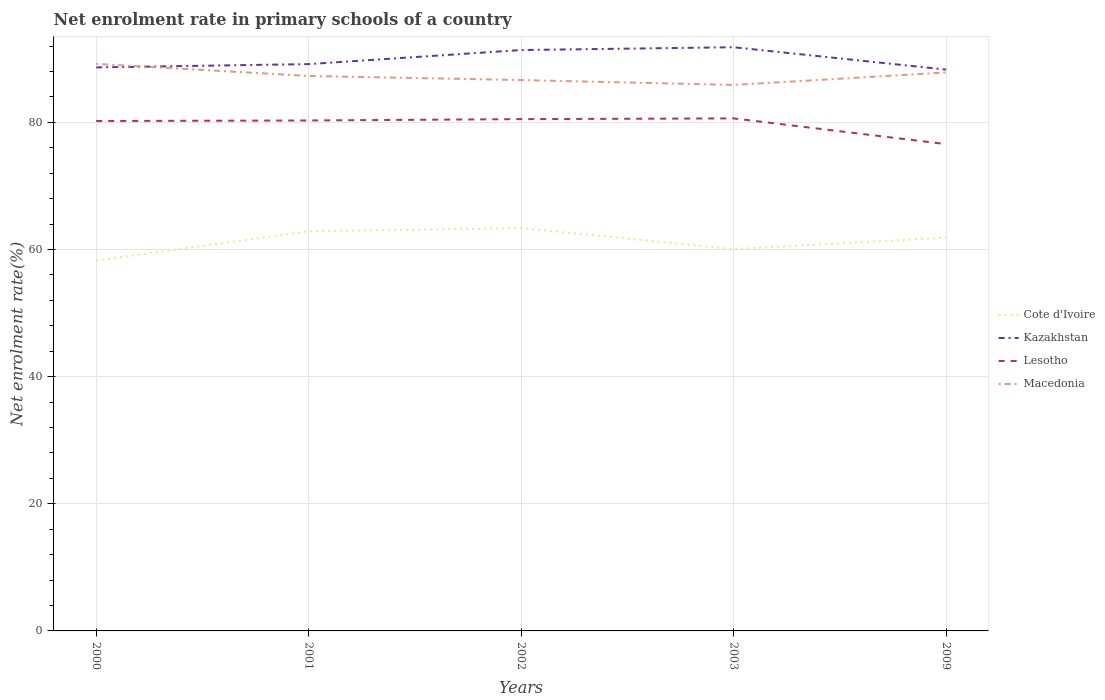How many different coloured lines are there?
Provide a short and direct response. 4. Across all years, what is the maximum net enrolment rate in primary schools in Macedonia?
Your answer should be very brief. 85.88. What is the total net enrolment rate in primary schools in Lesotho in the graph?
Your answer should be compact. 3.72. What is the difference between the highest and the second highest net enrolment rate in primary schools in Lesotho?
Your answer should be very brief. 4.05. What is the difference between the highest and the lowest net enrolment rate in primary schools in Cote d'Ivoire?
Ensure brevity in your answer.  3. Is the net enrolment rate in primary schools in Macedonia strictly greater than the net enrolment rate in primary schools in Lesotho over the years?
Ensure brevity in your answer.  No. What is the difference between two consecutive major ticks on the Y-axis?
Offer a terse response. 20. Does the graph contain any zero values?
Give a very brief answer. No. Does the graph contain grids?
Provide a succinct answer. Yes. How are the legend labels stacked?
Offer a very short reply. Vertical. What is the title of the graph?
Your response must be concise. Net enrolment rate in primary schools of a country. Does "Sierra Leone" appear as one of the legend labels in the graph?
Your answer should be compact. No. What is the label or title of the X-axis?
Provide a succinct answer. Years. What is the label or title of the Y-axis?
Make the answer very short. Net enrolment rate(%). What is the Net enrolment rate(%) in Cote d'Ivoire in 2000?
Your response must be concise. 58.26. What is the Net enrolment rate(%) of Kazakhstan in 2000?
Make the answer very short. 88.63. What is the Net enrolment rate(%) of Lesotho in 2000?
Your answer should be compact. 80.2. What is the Net enrolment rate(%) of Macedonia in 2000?
Give a very brief answer. 89.19. What is the Net enrolment rate(%) in Cote d'Ivoire in 2001?
Give a very brief answer. 62.86. What is the Net enrolment rate(%) in Kazakhstan in 2001?
Your answer should be very brief. 89.15. What is the Net enrolment rate(%) of Lesotho in 2001?
Provide a succinct answer. 80.29. What is the Net enrolment rate(%) of Macedonia in 2001?
Your answer should be very brief. 87.29. What is the Net enrolment rate(%) of Cote d'Ivoire in 2002?
Make the answer very short. 63.36. What is the Net enrolment rate(%) of Kazakhstan in 2002?
Your response must be concise. 91.36. What is the Net enrolment rate(%) of Lesotho in 2002?
Offer a terse response. 80.5. What is the Net enrolment rate(%) in Macedonia in 2002?
Provide a succinct answer. 86.64. What is the Net enrolment rate(%) in Cote d'Ivoire in 2003?
Offer a terse response. 60.05. What is the Net enrolment rate(%) of Kazakhstan in 2003?
Make the answer very short. 91.81. What is the Net enrolment rate(%) of Lesotho in 2003?
Provide a succinct answer. 80.61. What is the Net enrolment rate(%) of Macedonia in 2003?
Your response must be concise. 85.88. What is the Net enrolment rate(%) in Cote d'Ivoire in 2009?
Your answer should be very brief. 61.86. What is the Net enrolment rate(%) of Kazakhstan in 2009?
Provide a succinct answer. 88.29. What is the Net enrolment rate(%) of Lesotho in 2009?
Give a very brief answer. 76.57. What is the Net enrolment rate(%) of Macedonia in 2009?
Provide a short and direct response. 87.84. Across all years, what is the maximum Net enrolment rate(%) in Cote d'Ivoire?
Your answer should be compact. 63.36. Across all years, what is the maximum Net enrolment rate(%) of Kazakhstan?
Keep it short and to the point. 91.81. Across all years, what is the maximum Net enrolment rate(%) in Lesotho?
Your answer should be compact. 80.61. Across all years, what is the maximum Net enrolment rate(%) of Macedonia?
Keep it short and to the point. 89.19. Across all years, what is the minimum Net enrolment rate(%) in Cote d'Ivoire?
Make the answer very short. 58.26. Across all years, what is the minimum Net enrolment rate(%) in Kazakhstan?
Your answer should be very brief. 88.29. Across all years, what is the minimum Net enrolment rate(%) of Lesotho?
Provide a succinct answer. 76.57. Across all years, what is the minimum Net enrolment rate(%) of Macedonia?
Your answer should be compact. 85.88. What is the total Net enrolment rate(%) of Cote d'Ivoire in the graph?
Keep it short and to the point. 306.39. What is the total Net enrolment rate(%) of Kazakhstan in the graph?
Ensure brevity in your answer.  449.24. What is the total Net enrolment rate(%) of Lesotho in the graph?
Provide a short and direct response. 398.16. What is the total Net enrolment rate(%) of Macedonia in the graph?
Your answer should be very brief. 436.83. What is the difference between the Net enrolment rate(%) in Cote d'Ivoire in 2000 and that in 2001?
Ensure brevity in your answer.  -4.6. What is the difference between the Net enrolment rate(%) of Kazakhstan in 2000 and that in 2001?
Make the answer very short. -0.52. What is the difference between the Net enrolment rate(%) in Lesotho in 2000 and that in 2001?
Offer a terse response. -0.09. What is the difference between the Net enrolment rate(%) in Macedonia in 2000 and that in 2001?
Keep it short and to the point. 1.9. What is the difference between the Net enrolment rate(%) in Cote d'Ivoire in 2000 and that in 2002?
Provide a succinct answer. -5.1. What is the difference between the Net enrolment rate(%) in Kazakhstan in 2000 and that in 2002?
Your response must be concise. -2.73. What is the difference between the Net enrolment rate(%) in Lesotho in 2000 and that in 2002?
Provide a succinct answer. -0.3. What is the difference between the Net enrolment rate(%) in Macedonia in 2000 and that in 2002?
Your response must be concise. 2.54. What is the difference between the Net enrolment rate(%) of Cote d'Ivoire in 2000 and that in 2003?
Provide a short and direct response. -1.8. What is the difference between the Net enrolment rate(%) of Kazakhstan in 2000 and that in 2003?
Offer a terse response. -3.17. What is the difference between the Net enrolment rate(%) in Lesotho in 2000 and that in 2003?
Your answer should be compact. -0.41. What is the difference between the Net enrolment rate(%) of Macedonia in 2000 and that in 2003?
Provide a short and direct response. 3.31. What is the difference between the Net enrolment rate(%) in Kazakhstan in 2000 and that in 2009?
Your answer should be compact. 0.34. What is the difference between the Net enrolment rate(%) of Lesotho in 2000 and that in 2009?
Your answer should be compact. 3.64. What is the difference between the Net enrolment rate(%) of Macedonia in 2000 and that in 2009?
Offer a very short reply. 1.35. What is the difference between the Net enrolment rate(%) of Cote d'Ivoire in 2001 and that in 2002?
Your answer should be very brief. -0.5. What is the difference between the Net enrolment rate(%) of Kazakhstan in 2001 and that in 2002?
Make the answer very short. -2.21. What is the difference between the Net enrolment rate(%) in Lesotho in 2001 and that in 2002?
Make the answer very short. -0.21. What is the difference between the Net enrolment rate(%) of Macedonia in 2001 and that in 2002?
Your response must be concise. 0.64. What is the difference between the Net enrolment rate(%) in Cote d'Ivoire in 2001 and that in 2003?
Offer a very short reply. 2.81. What is the difference between the Net enrolment rate(%) in Kazakhstan in 2001 and that in 2003?
Provide a short and direct response. -2.65. What is the difference between the Net enrolment rate(%) in Lesotho in 2001 and that in 2003?
Provide a succinct answer. -0.33. What is the difference between the Net enrolment rate(%) in Macedonia in 2001 and that in 2003?
Keep it short and to the point. 1.41. What is the difference between the Net enrolment rate(%) of Cote d'Ivoire in 2001 and that in 2009?
Offer a very short reply. 1. What is the difference between the Net enrolment rate(%) in Kazakhstan in 2001 and that in 2009?
Ensure brevity in your answer.  0.86. What is the difference between the Net enrolment rate(%) in Lesotho in 2001 and that in 2009?
Keep it short and to the point. 3.72. What is the difference between the Net enrolment rate(%) in Macedonia in 2001 and that in 2009?
Offer a very short reply. -0.55. What is the difference between the Net enrolment rate(%) in Cote d'Ivoire in 2002 and that in 2003?
Your response must be concise. 3.3. What is the difference between the Net enrolment rate(%) of Kazakhstan in 2002 and that in 2003?
Your answer should be compact. -0.44. What is the difference between the Net enrolment rate(%) in Lesotho in 2002 and that in 2003?
Keep it short and to the point. -0.11. What is the difference between the Net enrolment rate(%) in Macedonia in 2002 and that in 2003?
Make the answer very short. 0.77. What is the difference between the Net enrolment rate(%) in Cote d'Ivoire in 2002 and that in 2009?
Your response must be concise. 1.5. What is the difference between the Net enrolment rate(%) of Kazakhstan in 2002 and that in 2009?
Ensure brevity in your answer.  3.08. What is the difference between the Net enrolment rate(%) in Lesotho in 2002 and that in 2009?
Your response must be concise. 3.93. What is the difference between the Net enrolment rate(%) of Macedonia in 2002 and that in 2009?
Offer a terse response. -1.19. What is the difference between the Net enrolment rate(%) in Cote d'Ivoire in 2003 and that in 2009?
Your response must be concise. -1.8. What is the difference between the Net enrolment rate(%) of Kazakhstan in 2003 and that in 2009?
Your answer should be very brief. 3.52. What is the difference between the Net enrolment rate(%) in Lesotho in 2003 and that in 2009?
Give a very brief answer. 4.05. What is the difference between the Net enrolment rate(%) in Macedonia in 2003 and that in 2009?
Offer a very short reply. -1.96. What is the difference between the Net enrolment rate(%) in Cote d'Ivoire in 2000 and the Net enrolment rate(%) in Kazakhstan in 2001?
Provide a succinct answer. -30.89. What is the difference between the Net enrolment rate(%) in Cote d'Ivoire in 2000 and the Net enrolment rate(%) in Lesotho in 2001?
Make the answer very short. -22.03. What is the difference between the Net enrolment rate(%) in Cote d'Ivoire in 2000 and the Net enrolment rate(%) in Macedonia in 2001?
Offer a terse response. -29.03. What is the difference between the Net enrolment rate(%) of Kazakhstan in 2000 and the Net enrolment rate(%) of Lesotho in 2001?
Offer a terse response. 8.35. What is the difference between the Net enrolment rate(%) of Kazakhstan in 2000 and the Net enrolment rate(%) of Macedonia in 2001?
Give a very brief answer. 1.35. What is the difference between the Net enrolment rate(%) in Lesotho in 2000 and the Net enrolment rate(%) in Macedonia in 2001?
Keep it short and to the point. -7.09. What is the difference between the Net enrolment rate(%) of Cote d'Ivoire in 2000 and the Net enrolment rate(%) of Kazakhstan in 2002?
Keep it short and to the point. -33.11. What is the difference between the Net enrolment rate(%) of Cote d'Ivoire in 2000 and the Net enrolment rate(%) of Lesotho in 2002?
Give a very brief answer. -22.24. What is the difference between the Net enrolment rate(%) in Cote d'Ivoire in 2000 and the Net enrolment rate(%) in Macedonia in 2002?
Ensure brevity in your answer.  -28.39. What is the difference between the Net enrolment rate(%) in Kazakhstan in 2000 and the Net enrolment rate(%) in Lesotho in 2002?
Provide a short and direct response. 8.13. What is the difference between the Net enrolment rate(%) of Kazakhstan in 2000 and the Net enrolment rate(%) of Macedonia in 2002?
Keep it short and to the point. 1.99. What is the difference between the Net enrolment rate(%) of Lesotho in 2000 and the Net enrolment rate(%) of Macedonia in 2002?
Provide a succinct answer. -6.44. What is the difference between the Net enrolment rate(%) of Cote d'Ivoire in 2000 and the Net enrolment rate(%) of Kazakhstan in 2003?
Your answer should be compact. -33.55. What is the difference between the Net enrolment rate(%) of Cote d'Ivoire in 2000 and the Net enrolment rate(%) of Lesotho in 2003?
Your answer should be very brief. -22.36. What is the difference between the Net enrolment rate(%) in Cote d'Ivoire in 2000 and the Net enrolment rate(%) in Macedonia in 2003?
Offer a very short reply. -27.62. What is the difference between the Net enrolment rate(%) of Kazakhstan in 2000 and the Net enrolment rate(%) of Lesotho in 2003?
Keep it short and to the point. 8.02. What is the difference between the Net enrolment rate(%) of Kazakhstan in 2000 and the Net enrolment rate(%) of Macedonia in 2003?
Ensure brevity in your answer.  2.76. What is the difference between the Net enrolment rate(%) in Lesotho in 2000 and the Net enrolment rate(%) in Macedonia in 2003?
Keep it short and to the point. -5.68. What is the difference between the Net enrolment rate(%) of Cote d'Ivoire in 2000 and the Net enrolment rate(%) of Kazakhstan in 2009?
Keep it short and to the point. -30.03. What is the difference between the Net enrolment rate(%) of Cote d'Ivoire in 2000 and the Net enrolment rate(%) of Lesotho in 2009?
Give a very brief answer. -18.31. What is the difference between the Net enrolment rate(%) in Cote d'Ivoire in 2000 and the Net enrolment rate(%) in Macedonia in 2009?
Your answer should be compact. -29.58. What is the difference between the Net enrolment rate(%) in Kazakhstan in 2000 and the Net enrolment rate(%) in Lesotho in 2009?
Ensure brevity in your answer.  12.07. What is the difference between the Net enrolment rate(%) of Kazakhstan in 2000 and the Net enrolment rate(%) of Macedonia in 2009?
Give a very brief answer. 0.8. What is the difference between the Net enrolment rate(%) in Lesotho in 2000 and the Net enrolment rate(%) in Macedonia in 2009?
Provide a short and direct response. -7.64. What is the difference between the Net enrolment rate(%) in Cote d'Ivoire in 2001 and the Net enrolment rate(%) in Kazakhstan in 2002?
Ensure brevity in your answer.  -28.5. What is the difference between the Net enrolment rate(%) of Cote d'Ivoire in 2001 and the Net enrolment rate(%) of Lesotho in 2002?
Your answer should be very brief. -17.64. What is the difference between the Net enrolment rate(%) of Cote d'Ivoire in 2001 and the Net enrolment rate(%) of Macedonia in 2002?
Your response must be concise. -23.78. What is the difference between the Net enrolment rate(%) of Kazakhstan in 2001 and the Net enrolment rate(%) of Lesotho in 2002?
Your response must be concise. 8.65. What is the difference between the Net enrolment rate(%) of Kazakhstan in 2001 and the Net enrolment rate(%) of Macedonia in 2002?
Offer a terse response. 2.51. What is the difference between the Net enrolment rate(%) of Lesotho in 2001 and the Net enrolment rate(%) of Macedonia in 2002?
Offer a very short reply. -6.36. What is the difference between the Net enrolment rate(%) of Cote d'Ivoire in 2001 and the Net enrolment rate(%) of Kazakhstan in 2003?
Ensure brevity in your answer.  -28.94. What is the difference between the Net enrolment rate(%) in Cote d'Ivoire in 2001 and the Net enrolment rate(%) in Lesotho in 2003?
Provide a succinct answer. -17.75. What is the difference between the Net enrolment rate(%) of Cote d'Ivoire in 2001 and the Net enrolment rate(%) of Macedonia in 2003?
Your response must be concise. -23.01. What is the difference between the Net enrolment rate(%) of Kazakhstan in 2001 and the Net enrolment rate(%) of Lesotho in 2003?
Make the answer very short. 8.54. What is the difference between the Net enrolment rate(%) of Kazakhstan in 2001 and the Net enrolment rate(%) of Macedonia in 2003?
Give a very brief answer. 3.27. What is the difference between the Net enrolment rate(%) in Lesotho in 2001 and the Net enrolment rate(%) in Macedonia in 2003?
Provide a short and direct response. -5.59. What is the difference between the Net enrolment rate(%) in Cote d'Ivoire in 2001 and the Net enrolment rate(%) in Kazakhstan in 2009?
Your response must be concise. -25.43. What is the difference between the Net enrolment rate(%) in Cote d'Ivoire in 2001 and the Net enrolment rate(%) in Lesotho in 2009?
Give a very brief answer. -13.7. What is the difference between the Net enrolment rate(%) of Cote d'Ivoire in 2001 and the Net enrolment rate(%) of Macedonia in 2009?
Offer a terse response. -24.97. What is the difference between the Net enrolment rate(%) in Kazakhstan in 2001 and the Net enrolment rate(%) in Lesotho in 2009?
Give a very brief answer. 12.59. What is the difference between the Net enrolment rate(%) of Kazakhstan in 2001 and the Net enrolment rate(%) of Macedonia in 2009?
Your response must be concise. 1.31. What is the difference between the Net enrolment rate(%) of Lesotho in 2001 and the Net enrolment rate(%) of Macedonia in 2009?
Your response must be concise. -7.55. What is the difference between the Net enrolment rate(%) in Cote d'Ivoire in 2002 and the Net enrolment rate(%) in Kazakhstan in 2003?
Your answer should be very brief. -28.45. What is the difference between the Net enrolment rate(%) of Cote d'Ivoire in 2002 and the Net enrolment rate(%) of Lesotho in 2003?
Offer a very short reply. -17.25. What is the difference between the Net enrolment rate(%) of Cote d'Ivoire in 2002 and the Net enrolment rate(%) of Macedonia in 2003?
Keep it short and to the point. -22.52. What is the difference between the Net enrolment rate(%) of Kazakhstan in 2002 and the Net enrolment rate(%) of Lesotho in 2003?
Your answer should be very brief. 10.75. What is the difference between the Net enrolment rate(%) in Kazakhstan in 2002 and the Net enrolment rate(%) in Macedonia in 2003?
Provide a short and direct response. 5.49. What is the difference between the Net enrolment rate(%) in Lesotho in 2002 and the Net enrolment rate(%) in Macedonia in 2003?
Ensure brevity in your answer.  -5.38. What is the difference between the Net enrolment rate(%) of Cote d'Ivoire in 2002 and the Net enrolment rate(%) of Kazakhstan in 2009?
Provide a succinct answer. -24.93. What is the difference between the Net enrolment rate(%) of Cote d'Ivoire in 2002 and the Net enrolment rate(%) of Lesotho in 2009?
Your answer should be compact. -13.21. What is the difference between the Net enrolment rate(%) in Cote d'Ivoire in 2002 and the Net enrolment rate(%) in Macedonia in 2009?
Your answer should be compact. -24.48. What is the difference between the Net enrolment rate(%) of Kazakhstan in 2002 and the Net enrolment rate(%) of Lesotho in 2009?
Your answer should be compact. 14.8. What is the difference between the Net enrolment rate(%) in Kazakhstan in 2002 and the Net enrolment rate(%) in Macedonia in 2009?
Your answer should be compact. 3.53. What is the difference between the Net enrolment rate(%) of Lesotho in 2002 and the Net enrolment rate(%) of Macedonia in 2009?
Provide a succinct answer. -7.34. What is the difference between the Net enrolment rate(%) of Cote d'Ivoire in 2003 and the Net enrolment rate(%) of Kazakhstan in 2009?
Give a very brief answer. -28.23. What is the difference between the Net enrolment rate(%) of Cote d'Ivoire in 2003 and the Net enrolment rate(%) of Lesotho in 2009?
Ensure brevity in your answer.  -16.51. What is the difference between the Net enrolment rate(%) of Cote d'Ivoire in 2003 and the Net enrolment rate(%) of Macedonia in 2009?
Make the answer very short. -27.78. What is the difference between the Net enrolment rate(%) in Kazakhstan in 2003 and the Net enrolment rate(%) in Lesotho in 2009?
Your answer should be very brief. 15.24. What is the difference between the Net enrolment rate(%) of Kazakhstan in 2003 and the Net enrolment rate(%) of Macedonia in 2009?
Give a very brief answer. 3.97. What is the difference between the Net enrolment rate(%) of Lesotho in 2003 and the Net enrolment rate(%) of Macedonia in 2009?
Your response must be concise. -7.22. What is the average Net enrolment rate(%) of Cote d'Ivoire per year?
Keep it short and to the point. 61.28. What is the average Net enrolment rate(%) in Kazakhstan per year?
Offer a very short reply. 89.85. What is the average Net enrolment rate(%) in Lesotho per year?
Provide a short and direct response. 79.63. What is the average Net enrolment rate(%) in Macedonia per year?
Provide a succinct answer. 87.37. In the year 2000, what is the difference between the Net enrolment rate(%) of Cote d'Ivoire and Net enrolment rate(%) of Kazakhstan?
Provide a short and direct response. -30.38. In the year 2000, what is the difference between the Net enrolment rate(%) in Cote d'Ivoire and Net enrolment rate(%) in Lesotho?
Your response must be concise. -21.94. In the year 2000, what is the difference between the Net enrolment rate(%) of Cote d'Ivoire and Net enrolment rate(%) of Macedonia?
Ensure brevity in your answer.  -30.93. In the year 2000, what is the difference between the Net enrolment rate(%) in Kazakhstan and Net enrolment rate(%) in Lesotho?
Provide a short and direct response. 8.43. In the year 2000, what is the difference between the Net enrolment rate(%) of Kazakhstan and Net enrolment rate(%) of Macedonia?
Make the answer very short. -0.55. In the year 2000, what is the difference between the Net enrolment rate(%) in Lesotho and Net enrolment rate(%) in Macedonia?
Give a very brief answer. -8.99. In the year 2001, what is the difference between the Net enrolment rate(%) of Cote d'Ivoire and Net enrolment rate(%) of Kazakhstan?
Give a very brief answer. -26.29. In the year 2001, what is the difference between the Net enrolment rate(%) of Cote d'Ivoire and Net enrolment rate(%) of Lesotho?
Give a very brief answer. -17.42. In the year 2001, what is the difference between the Net enrolment rate(%) of Cote d'Ivoire and Net enrolment rate(%) of Macedonia?
Your answer should be very brief. -24.43. In the year 2001, what is the difference between the Net enrolment rate(%) of Kazakhstan and Net enrolment rate(%) of Lesotho?
Provide a short and direct response. 8.87. In the year 2001, what is the difference between the Net enrolment rate(%) of Kazakhstan and Net enrolment rate(%) of Macedonia?
Provide a succinct answer. 1.86. In the year 2001, what is the difference between the Net enrolment rate(%) in Lesotho and Net enrolment rate(%) in Macedonia?
Give a very brief answer. -7. In the year 2002, what is the difference between the Net enrolment rate(%) in Cote d'Ivoire and Net enrolment rate(%) in Kazakhstan?
Your answer should be very brief. -28.01. In the year 2002, what is the difference between the Net enrolment rate(%) of Cote d'Ivoire and Net enrolment rate(%) of Lesotho?
Provide a succinct answer. -17.14. In the year 2002, what is the difference between the Net enrolment rate(%) of Cote d'Ivoire and Net enrolment rate(%) of Macedonia?
Give a very brief answer. -23.29. In the year 2002, what is the difference between the Net enrolment rate(%) in Kazakhstan and Net enrolment rate(%) in Lesotho?
Keep it short and to the point. 10.87. In the year 2002, what is the difference between the Net enrolment rate(%) in Kazakhstan and Net enrolment rate(%) in Macedonia?
Ensure brevity in your answer.  4.72. In the year 2002, what is the difference between the Net enrolment rate(%) of Lesotho and Net enrolment rate(%) of Macedonia?
Provide a short and direct response. -6.15. In the year 2003, what is the difference between the Net enrolment rate(%) of Cote d'Ivoire and Net enrolment rate(%) of Kazakhstan?
Ensure brevity in your answer.  -31.75. In the year 2003, what is the difference between the Net enrolment rate(%) in Cote d'Ivoire and Net enrolment rate(%) in Lesotho?
Offer a terse response. -20.56. In the year 2003, what is the difference between the Net enrolment rate(%) in Cote d'Ivoire and Net enrolment rate(%) in Macedonia?
Provide a short and direct response. -25.82. In the year 2003, what is the difference between the Net enrolment rate(%) in Kazakhstan and Net enrolment rate(%) in Lesotho?
Your response must be concise. 11.19. In the year 2003, what is the difference between the Net enrolment rate(%) in Kazakhstan and Net enrolment rate(%) in Macedonia?
Ensure brevity in your answer.  5.93. In the year 2003, what is the difference between the Net enrolment rate(%) of Lesotho and Net enrolment rate(%) of Macedonia?
Keep it short and to the point. -5.26. In the year 2009, what is the difference between the Net enrolment rate(%) in Cote d'Ivoire and Net enrolment rate(%) in Kazakhstan?
Offer a terse response. -26.43. In the year 2009, what is the difference between the Net enrolment rate(%) in Cote d'Ivoire and Net enrolment rate(%) in Lesotho?
Offer a terse response. -14.71. In the year 2009, what is the difference between the Net enrolment rate(%) in Cote d'Ivoire and Net enrolment rate(%) in Macedonia?
Keep it short and to the point. -25.98. In the year 2009, what is the difference between the Net enrolment rate(%) in Kazakhstan and Net enrolment rate(%) in Lesotho?
Keep it short and to the point. 11.72. In the year 2009, what is the difference between the Net enrolment rate(%) in Kazakhstan and Net enrolment rate(%) in Macedonia?
Make the answer very short. 0.45. In the year 2009, what is the difference between the Net enrolment rate(%) in Lesotho and Net enrolment rate(%) in Macedonia?
Offer a terse response. -11.27. What is the ratio of the Net enrolment rate(%) of Cote d'Ivoire in 2000 to that in 2001?
Give a very brief answer. 0.93. What is the ratio of the Net enrolment rate(%) in Kazakhstan in 2000 to that in 2001?
Your response must be concise. 0.99. What is the ratio of the Net enrolment rate(%) of Lesotho in 2000 to that in 2001?
Give a very brief answer. 1. What is the ratio of the Net enrolment rate(%) in Macedonia in 2000 to that in 2001?
Make the answer very short. 1.02. What is the ratio of the Net enrolment rate(%) of Cote d'Ivoire in 2000 to that in 2002?
Provide a short and direct response. 0.92. What is the ratio of the Net enrolment rate(%) in Kazakhstan in 2000 to that in 2002?
Offer a terse response. 0.97. What is the ratio of the Net enrolment rate(%) in Lesotho in 2000 to that in 2002?
Offer a terse response. 1. What is the ratio of the Net enrolment rate(%) in Macedonia in 2000 to that in 2002?
Make the answer very short. 1.03. What is the ratio of the Net enrolment rate(%) of Cote d'Ivoire in 2000 to that in 2003?
Keep it short and to the point. 0.97. What is the ratio of the Net enrolment rate(%) in Kazakhstan in 2000 to that in 2003?
Ensure brevity in your answer.  0.97. What is the ratio of the Net enrolment rate(%) in Lesotho in 2000 to that in 2003?
Ensure brevity in your answer.  0.99. What is the ratio of the Net enrolment rate(%) in Macedonia in 2000 to that in 2003?
Your answer should be very brief. 1.04. What is the ratio of the Net enrolment rate(%) of Cote d'Ivoire in 2000 to that in 2009?
Your answer should be very brief. 0.94. What is the ratio of the Net enrolment rate(%) of Lesotho in 2000 to that in 2009?
Ensure brevity in your answer.  1.05. What is the ratio of the Net enrolment rate(%) in Macedonia in 2000 to that in 2009?
Keep it short and to the point. 1.02. What is the ratio of the Net enrolment rate(%) in Cote d'Ivoire in 2001 to that in 2002?
Offer a very short reply. 0.99. What is the ratio of the Net enrolment rate(%) in Kazakhstan in 2001 to that in 2002?
Ensure brevity in your answer.  0.98. What is the ratio of the Net enrolment rate(%) of Lesotho in 2001 to that in 2002?
Make the answer very short. 1. What is the ratio of the Net enrolment rate(%) of Macedonia in 2001 to that in 2002?
Make the answer very short. 1.01. What is the ratio of the Net enrolment rate(%) in Cote d'Ivoire in 2001 to that in 2003?
Offer a very short reply. 1.05. What is the ratio of the Net enrolment rate(%) of Kazakhstan in 2001 to that in 2003?
Give a very brief answer. 0.97. What is the ratio of the Net enrolment rate(%) in Lesotho in 2001 to that in 2003?
Provide a succinct answer. 1. What is the ratio of the Net enrolment rate(%) of Macedonia in 2001 to that in 2003?
Your answer should be compact. 1.02. What is the ratio of the Net enrolment rate(%) of Cote d'Ivoire in 2001 to that in 2009?
Provide a short and direct response. 1.02. What is the ratio of the Net enrolment rate(%) in Kazakhstan in 2001 to that in 2009?
Make the answer very short. 1.01. What is the ratio of the Net enrolment rate(%) in Lesotho in 2001 to that in 2009?
Ensure brevity in your answer.  1.05. What is the ratio of the Net enrolment rate(%) of Macedonia in 2001 to that in 2009?
Offer a very short reply. 0.99. What is the ratio of the Net enrolment rate(%) of Cote d'Ivoire in 2002 to that in 2003?
Provide a succinct answer. 1.05. What is the ratio of the Net enrolment rate(%) of Macedonia in 2002 to that in 2003?
Provide a short and direct response. 1.01. What is the ratio of the Net enrolment rate(%) of Cote d'Ivoire in 2002 to that in 2009?
Give a very brief answer. 1.02. What is the ratio of the Net enrolment rate(%) in Kazakhstan in 2002 to that in 2009?
Your answer should be compact. 1.03. What is the ratio of the Net enrolment rate(%) in Lesotho in 2002 to that in 2009?
Your answer should be very brief. 1.05. What is the ratio of the Net enrolment rate(%) in Macedonia in 2002 to that in 2009?
Provide a short and direct response. 0.99. What is the ratio of the Net enrolment rate(%) of Cote d'Ivoire in 2003 to that in 2009?
Give a very brief answer. 0.97. What is the ratio of the Net enrolment rate(%) of Kazakhstan in 2003 to that in 2009?
Offer a terse response. 1.04. What is the ratio of the Net enrolment rate(%) in Lesotho in 2003 to that in 2009?
Your response must be concise. 1.05. What is the ratio of the Net enrolment rate(%) in Macedonia in 2003 to that in 2009?
Provide a succinct answer. 0.98. What is the difference between the highest and the second highest Net enrolment rate(%) in Cote d'Ivoire?
Your answer should be compact. 0.5. What is the difference between the highest and the second highest Net enrolment rate(%) of Kazakhstan?
Your answer should be very brief. 0.44. What is the difference between the highest and the second highest Net enrolment rate(%) of Lesotho?
Ensure brevity in your answer.  0.11. What is the difference between the highest and the second highest Net enrolment rate(%) in Macedonia?
Your answer should be very brief. 1.35. What is the difference between the highest and the lowest Net enrolment rate(%) of Cote d'Ivoire?
Offer a terse response. 5.1. What is the difference between the highest and the lowest Net enrolment rate(%) of Kazakhstan?
Your answer should be very brief. 3.52. What is the difference between the highest and the lowest Net enrolment rate(%) in Lesotho?
Give a very brief answer. 4.05. What is the difference between the highest and the lowest Net enrolment rate(%) in Macedonia?
Give a very brief answer. 3.31. 